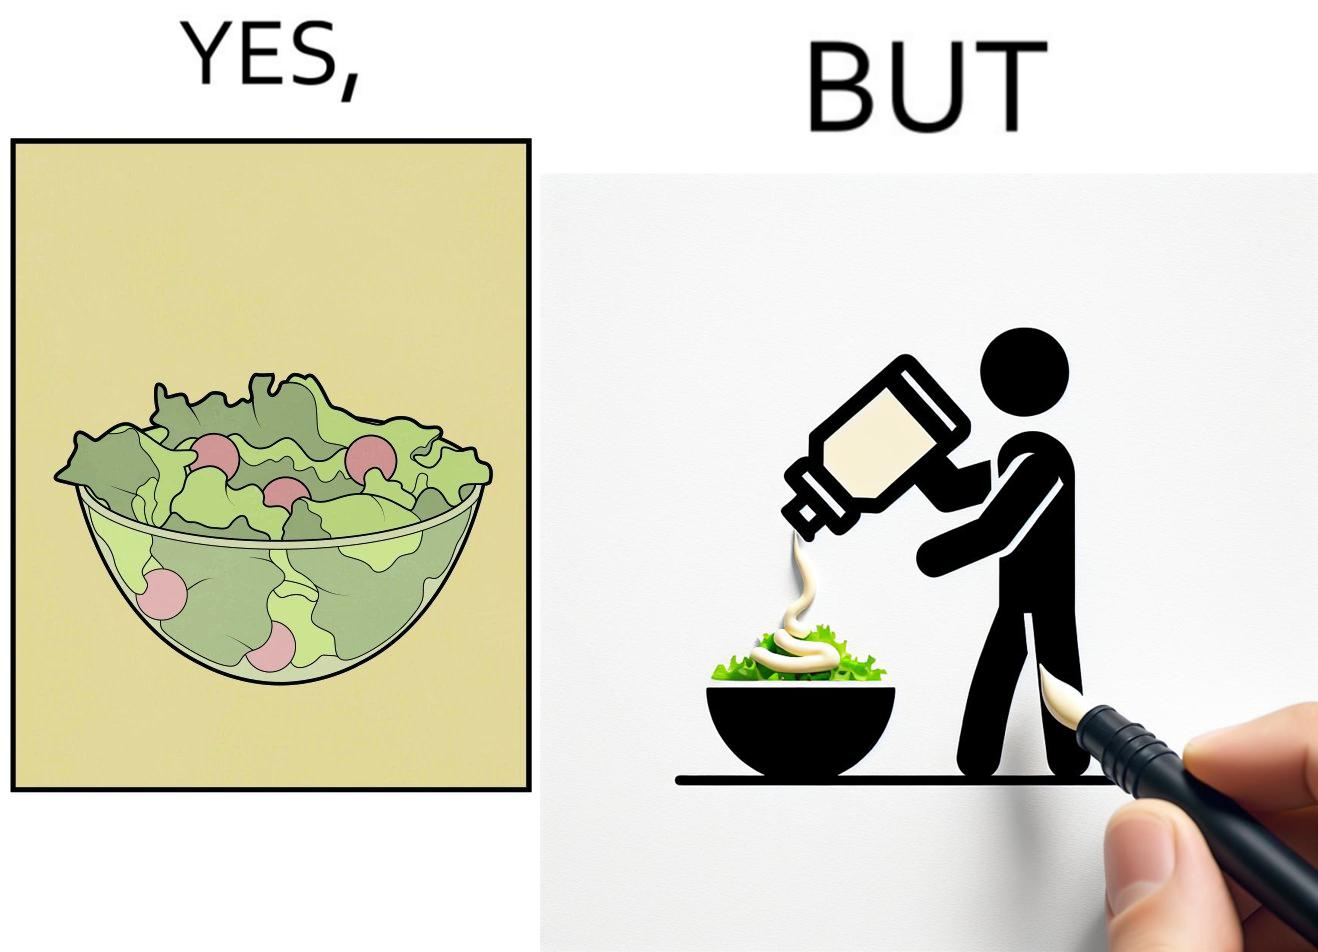What does this image depict? The image is ironical, as salad in a bowl by itself is very healthy. However, when people have it with Mayonnaise sauce to improve the taste, it is not healthy anymore, and defeats the point of having nutrient-rich salad altogether. 